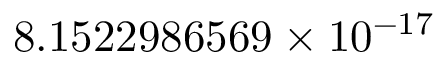Convert formula to latex. <formula><loc_0><loc_0><loc_500><loc_500>8 . 1 5 2 2 9 8 6 5 6 9 \times 1 0 ^ { - 1 7 }</formula> 